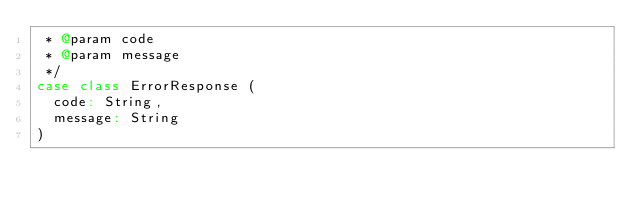Convert code to text. <code><loc_0><loc_0><loc_500><loc_500><_Scala_> * @param code 
 * @param message 
 */
case class ErrorResponse (
  code: String,
  message: String
)

</code> 